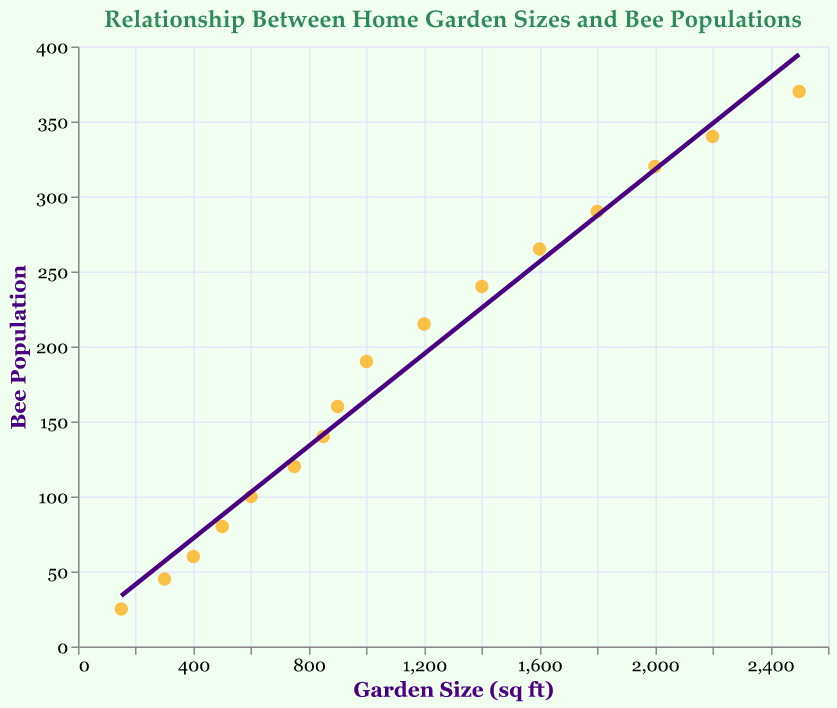What is the title of the plot? The title of the plot is clearly displayed at the top and it reads: "Relationship Between Home Garden Sizes and Bee Populations"
Answer: Relationship Between Home Garden Sizes and Bee Populations How many data points are plotted on the scatter plot? Each pair of garden size and bee population represents one data point, and there are 16 pairs in the dataset provided.
Answer: 16 What is the color of the trend line? The trend line is represented by a solid line through the data points and it is colored in a shade of purple.
Answer: Purple Which garden size has the highest bee population? By looking at the highest point on the y-axis corresponding to bee population, the garden size is 2500 square feet with a bee population of 370.
Answer: 2500 square feet Is there a positive or negative relationship between garden size and bee population? The trend line slopes upwards from left to right, indicating a positive relationship between garden size and bee population.
Answer: Positive What is the bee population for a garden size of 1200 square feet? Find the data point where the x-axis value is 1200, and observe the corresponding y-axis value, which is 215.
Answer: 215 What is the bee population for the smallest garden size in the plot? Look at the data point with the smallest x-axis value (150 sqft), and the y-axis value for bee population is 25.
Answer: 25 Given the trend in the plot, if a garden size increases from 1000 square feet to 2000 square feet, what is the approximate increase in bee population? From the plot, for a 1000 square feet garden size, the bee population is 190, and for 2000 square feet, it is 320. The approximate increase is 320 - 190 = 130.
Answer: 130 